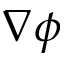Convert formula to latex. <formula><loc_0><loc_0><loc_500><loc_500>\nabla \phi</formula> 